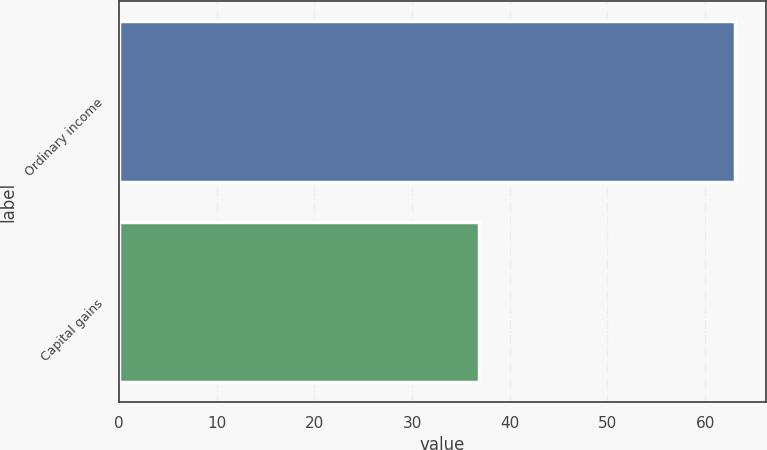<chart> <loc_0><loc_0><loc_500><loc_500><bar_chart><fcel>Ordinary income<fcel>Capital gains<nl><fcel>63.1<fcel>36.9<nl></chart> 